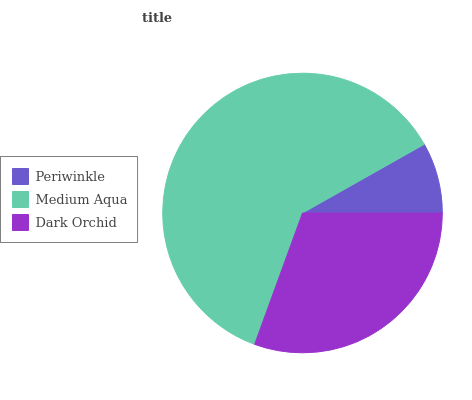Is Periwinkle the minimum?
Answer yes or no. Yes. Is Medium Aqua the maximum?
Answer yes or no. Yes. Is Dark Orchid the minimum?
Answer yes or no. No. Is Dark Orchid the maximum?
Answer yes or no. No. Is Medium Aqua greater than Dark Orchid?
Answer yes or no. Yes. Is Dark Orchid less than Medium Aqua?
Answer yes or no. Yes. Is Dark Orchid greater than Medium Aqua?
Answer yes or no. No. Is Medium Aqua less than Dark Orchid?
Answer yes or no. No. Is Dark Orchid the high median?
Answer yes or no. Yes. Is Dark Orchid the low median?
Answer yes or no. Yes. Is Periwinkle the high median?
Answer yes or no. No. Is Medium Aqua the low median?
Answer yes or no. No. 